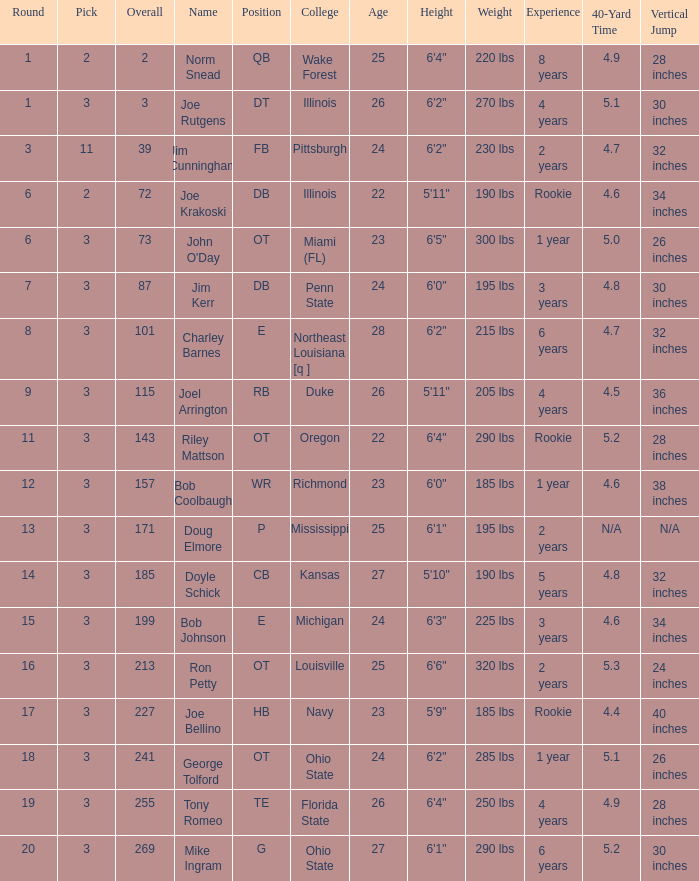How many overalls have charley barnes as the name, with a pick less than 3? None. 